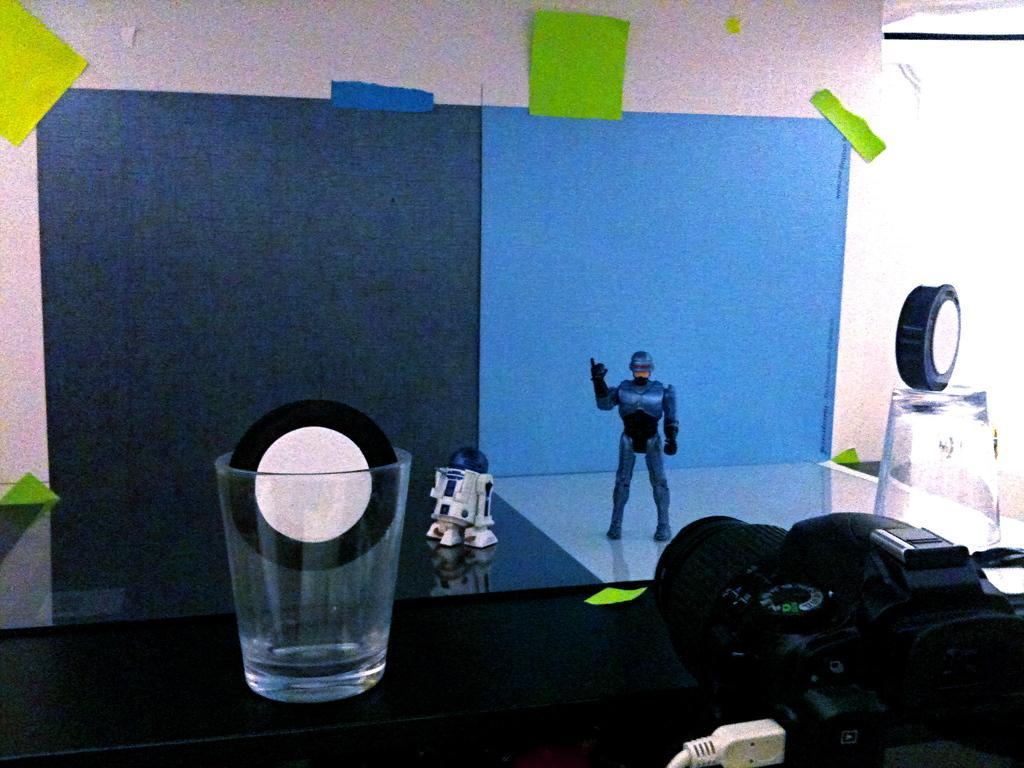Can you describe this image briefly? In this image at the bottom there is a table, on the table there is a glasses and some object, toy. In the background there are charts on the wall, and some light is coming out. 